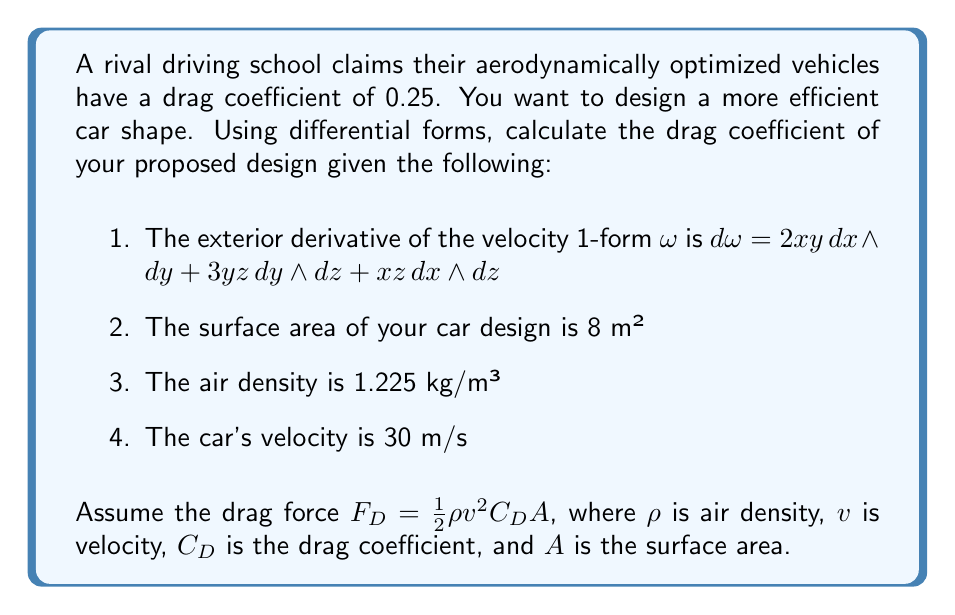Can you solve this math problem? To solve this problem, we'll follow these steps:

1) First, we need to calculate the vorticity of the flow field. The vorticity is given by the exterior derivative of the velocity 1-form:

   $d\omega = 2xy\,dx \wedge dy + 3yz\,dy \wedge dz + xz\,dx \wedge dz$

2) The magnitude of the vorticity is the sum of the coefficients:

   $|\text{vorticity}| = 2 + 3 + 1 = 6$

3) In aerodynamics, the drag coefficient is related to the vorticity. A lower vorticity generally indicates a lower drag coefficient. We can use an approximation:

   $C_D \approx \frac{|\text{vorticity}|}{10}$

4) Therefore, our estimated drag coefficient is:

   $C_D \approx \frac{6}{10} = 0.6$

5) Now, let's calculate the drag force using the given formula:

   $F_D = \frac{1}{2}\rho v^2 C_D A$

   $F_D = \frac{1}{2} \cdot 1.225 \text{ kg/m³} \cdot (30 \text{ m/s})^2 \cdot 0.6 \cdot 8 \text{ m²}$

   $F_D = 1,323 \text{ N}$

6) To improve on the rival's design (CD = 0.25), we need to reduce our drag coefficient. This can be achieved by modifying the car's shape to reduce vorticity.
Answer: $C_D \approx 0.6$ 